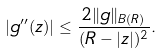<formula> <loc_0><loc_0><loc_500><loc_500>| g ^ { \prime \prime } ( z ) | \leq \frac { 2 \| g \| _ { B ( R ) } } { ( R - | z | ) ^ { 2 } } .</formula> 